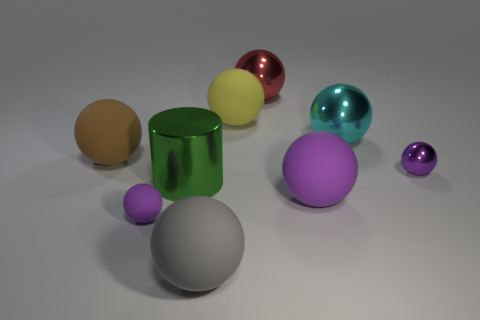Subtract all blue blocks. How many purple spheres are left? 3 Subtract all red balls. How many balls are left? 7 Subtract all red metal spheres. How many spheres are left? 7 Subtract all yellow spheres. Subtract all brown blocks. How many spheres are left? 7 Add 1 small green matte cylinders. How many objects exist? 10 Subtract all spheres. How many objects are left? 1 Add 1 big brown objects. How many big brown objects are left? 2 Add 4 large gray cylinders. How many large gray cylinders exist? 4 Subtract 0 cyan cylinders. How many objects are left? 9 Subtract all small green metallic cylinders. Subtract all large gray objects. How many objects are left? 8 